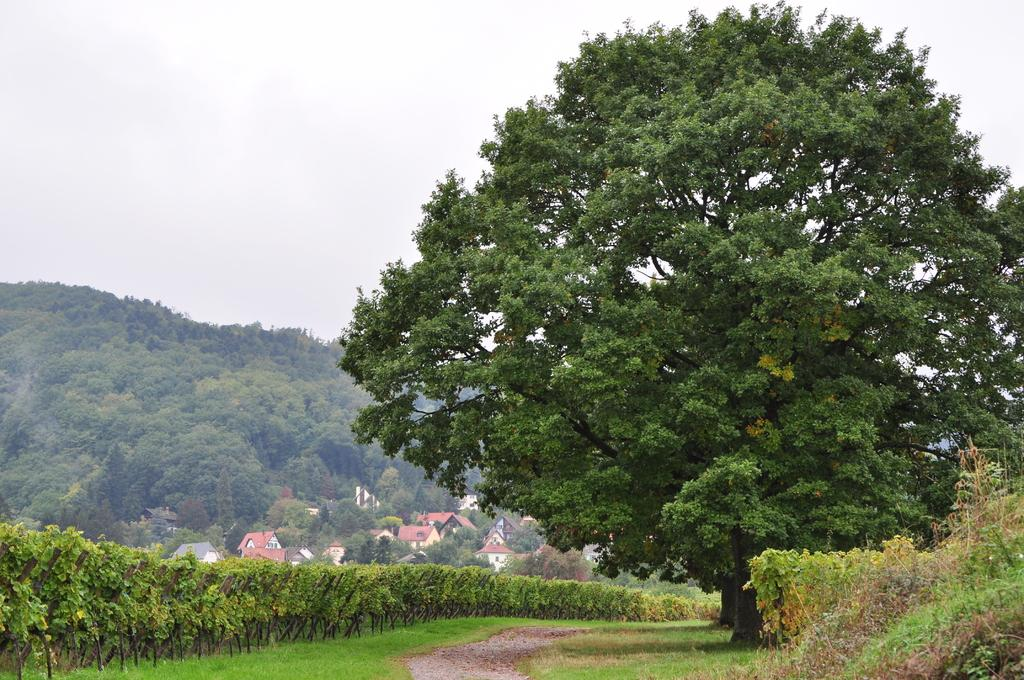What type of vegetation can be seen in the image? There are trees and plants in the image. What is at the bottom of the image? There is grass at the bottom of the image. What can be used for walking or traversing in the image? There is a walkway in the image. What is visible in the background of the image? There are trees, houses, and buildings in the background of the image. What is visible at the top of the image? The sky is visible at the top of the image. What historical event is depicted in the image? There is no historical event depicted in the image; it features trees, plants, grass, a walkway, and various structures in the background. What idea or concept is being conveyed through the image? The image does not convey a specific idea or concept; it is a visual representation of a natural and built environment. 